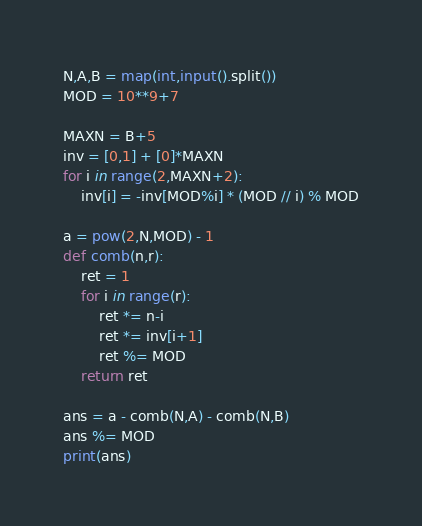Convert code to text. <code><loc_0><loc_0><loc_500><loc_500><_Python_>N,A,B = map(int,input().split())
MOD = 10**9+7

MAXN = B+5
inv = [0,1] + [0]*MAXN
for i in range(2,MAXN+2):
    inv[i] = -inv[MOD%i] * (MOD // i) % MOD

a = pow(2,N,MOD) - 1
def comb(n,r):
    ret = 1
    for i in range(r):
        ret *= n-i
        ret *= inv[i+1]
        ret %= MOD
    return ret

ans = a - comb(N,A) - comb(N,B)
ans %= MOD
print(ans)</code> 